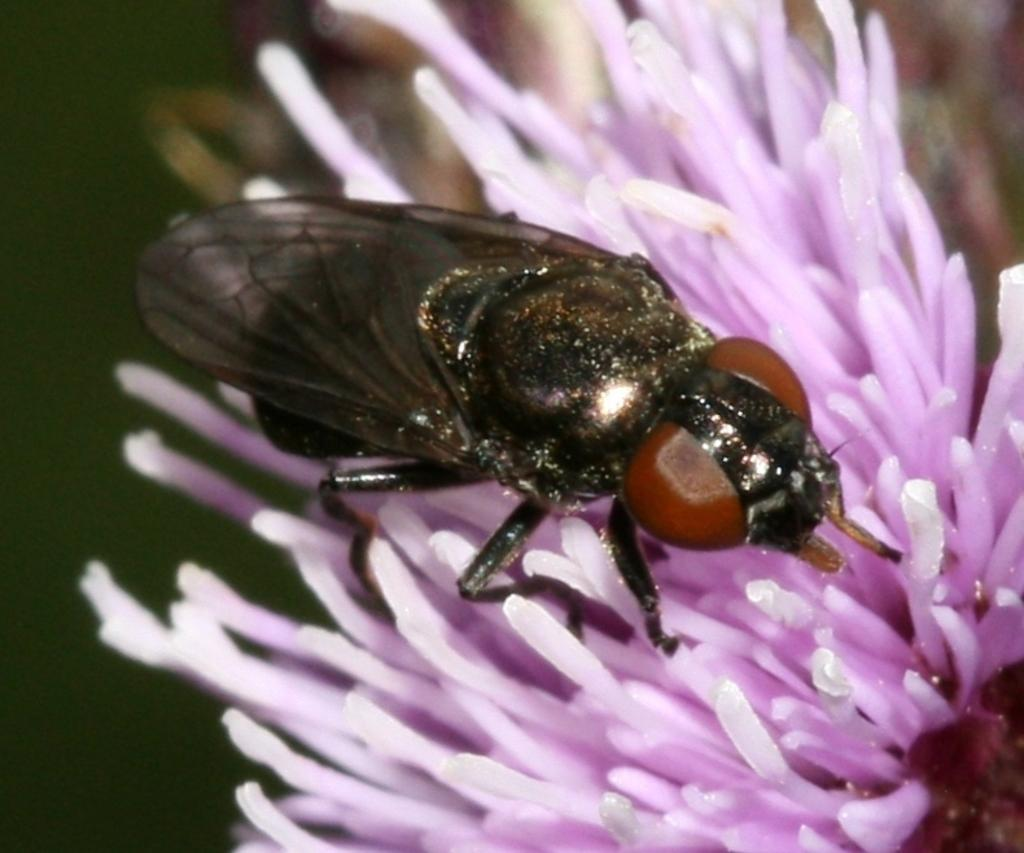What is present in the image? There is a fly and a flower in the image. Where is the fly located in relation to the flower? The fly is on the flower. What is the main focus of the image? The flower is in the center of the image. What type of alarm is the fly sounding in the image? There is no alarm present in the image; it features a fly on a flower. What kind of veil is covering the flower in the image? There is no veil covering the flower in the image; it is visible and not obstructed. 